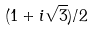<formula> <loc_0><loc_0><loc_500><loc_500>( 1 + i \sqrt { 3 } ) / 2</formula> 